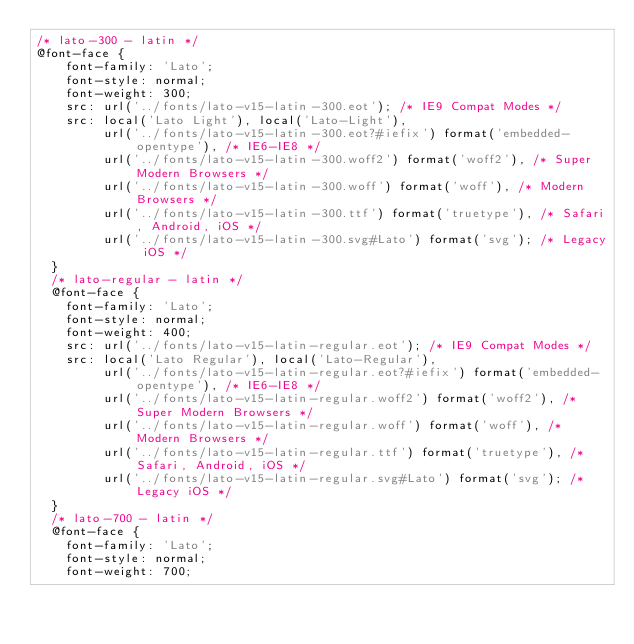Convert code to text. <code><loc_0><loc_0><loc_500><loc_500><_CSS_>/* lato-300 - latin */
@font-face {
    font-family: 'Lato';
    font-style: normal;
    font-weight: 300;
    src: url('../fonts/lato-v15-latin-300.eot'); /* IE9 Compat Modes */
    src: local('Lato Light'), local('Lato-Light'),
         url('../fonts/lato-v15-latin-300.eot?#iefix') format('embedded-opentype'), /* IE6-IE8 */
         url('../fonts/lato-v15-latin-300.woff2') format('woff2'), /* Super Modern Browsers */
         url('../fonts/lato-v15-latin-300.woff') format('woff'), /* Modern Browsers */
         url('../fonts/lato-v15-latin-300.ttf') format('truetype'), /* Safari, Android, iOS */
         url('../fonts/lato-v15-latin-300.svg#Lato') format('svg'); /* Legacy iOS */
  }
  /* lato-regular - latin */
  @font-face {
    font-family: 'Lato';
    font-style: normal;
    font-weight: 400;
    src: url('../fonts/lato-v15-latin-regular.eot'); /* IE9 Compat Modes */
    src: local('Lato Regular'), local('Lato-Regular'),
         url('../fonts/lato-v15-latin-regular.eot?#iefix') format('embedded-opentype'), /* IE6-IE8 */
         url('../fonts/lato-v15-latin-regular.woff2') format('woff2'), /* Super Modern Browsers */
         url('../fonts/lato-v15-latin-regular.woff') format('woff'), /* Modern Browsers */
         url('../fonts/lato-v15-latin-regular.ttf') format('truetype'), /* Safari, Android, iOS */
         url('../fonts/lato-v15-latin-regular.svg#Lato') format('svg'); /* Legacy iOS */
  }
  /* lato-700 - latin */
  @font-face {
    font-family: 'Lato';
    font-style: normal;
    font-weight: 700;</code> 